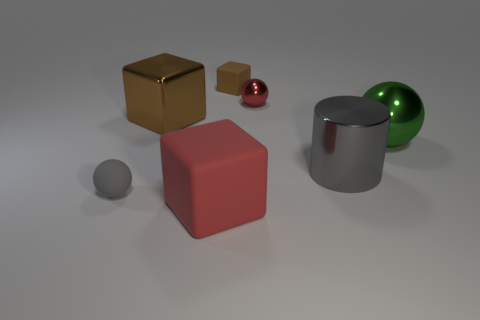Are there any other things that are the same shape as the large gray metallic thing?
Your answer should be compact. No. There is a tiny object in front of the large gray cylinder; does it have the same color as the metal object that is in front of the big green shiny object?
Provide a succinct answer. Yes. Is there a small matte object that has the same color as the metal cylinder?
Offer a very short reply. Yes. There is a thing that is the same color as the large matte block; what is it made of?
Your response must be concise. Metal. Is there a yellow matte cube of the same size as the brown matte thing?
Offer a terse response. No. How many things are either rubber objects behind the gray rubber sphere or small matte things that are on the left side of the small red shiny sphere?
Offer a very short reply. 2. What shape is the brown metal thing that is the same size as the green metallic sphere?
Provide a short and direct response. Cube. Are there any brown metallic objects of the same shape as the brown matte object?
Give a very brief answer. Yes. Are there fewer tiny gray spheres than rubber objects?
Provide a succinct answer. Yes. There is a red thing behind the gray metal cylinder; is its size the same as the matte cube behind the big green sphere?
Offer a very short reply. Yes. 